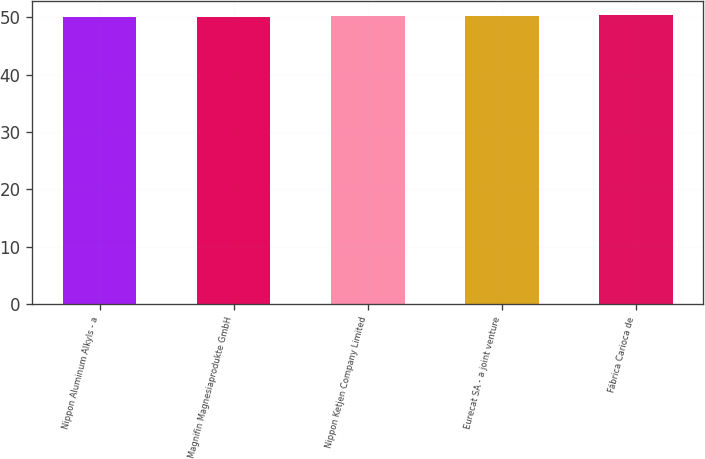Convert chart. <chart><loc_0><loc_0><loc_500><loc_500><bar_chart><fcel>Nippon Aluminum Alkyls - a<fcel>Magnifin Magnesiaprodukte GmbH<fcel>Nippon Ketjen Company Limited<fcel>Eurecat SA - a joint venture<fcel>Fábrica Carioca de<nl><fcel>50<fcel>50.1<fcel>50.2<fcel>50.3<fcel>50.4<nl></chart> 